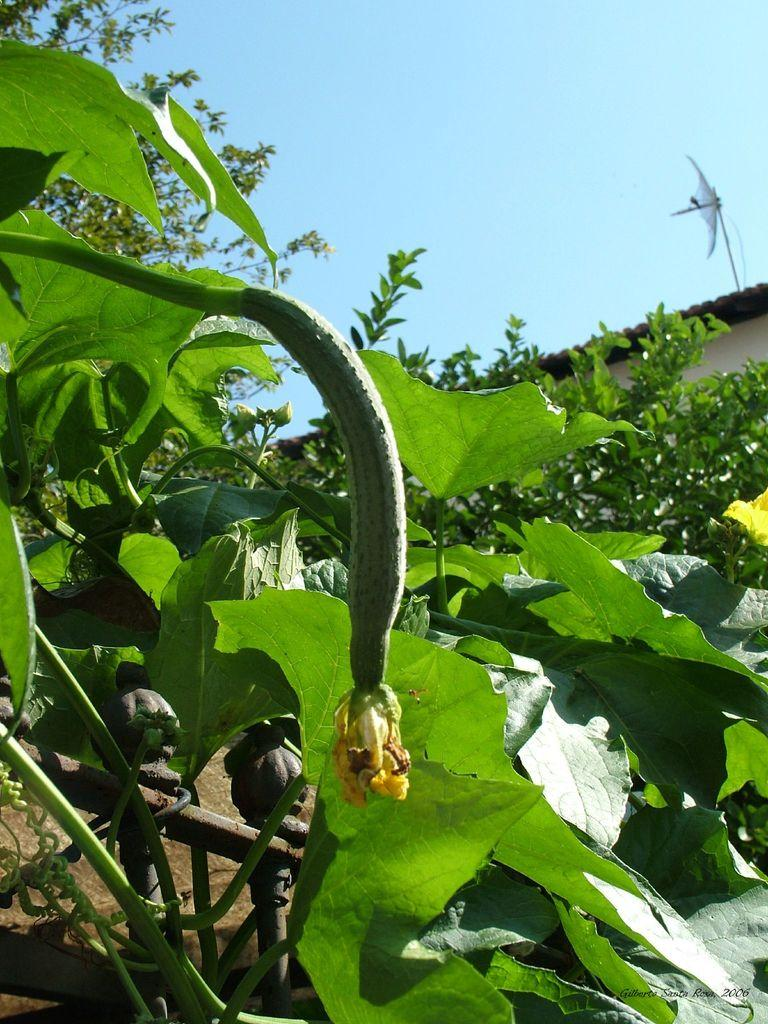What type of living organisms can be seen in the image? Plants can be seen in the image. What part of a building is visible behind the plants? A part of the house roof is visible behind the plants. What can be seen in the background of the image? The sky is visible in the background of the image. How does the spy use the pail to pull the plants in the image? There is no spy, pail, or action of pulling the plants in the image. The image only features plants, a part of a house roof, and the sky. 